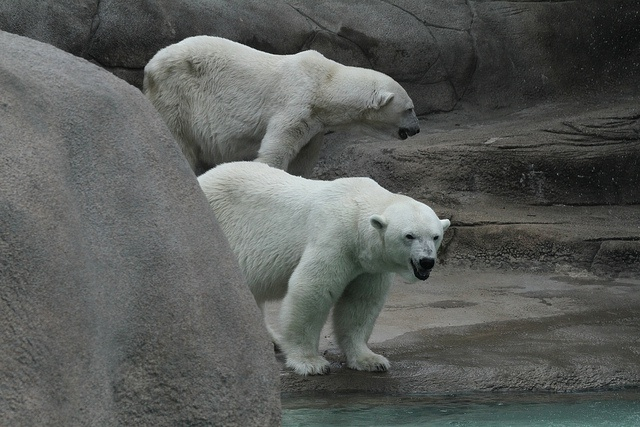Describe the objects in this image and their specific colors. I can see bear in gray, darkgray, lightgray, and black tones and bear in gray, darkgray, black, and lightgray tones in this image. 